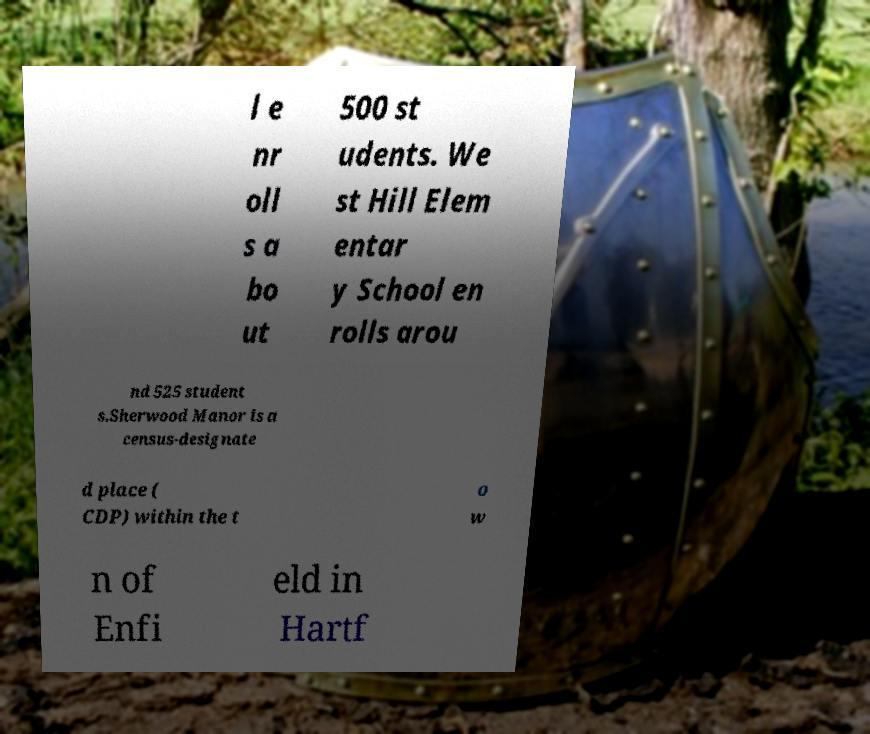Could you extract and type out the text from this image? l e nr oll s a bo ut 500 st udents. We st Hill Elem entar y School en rolls arou nd 525 student s.Sherwood Manor is a census-designate d place ( CDP) within the t o w n of Enfi eld in Hartf 